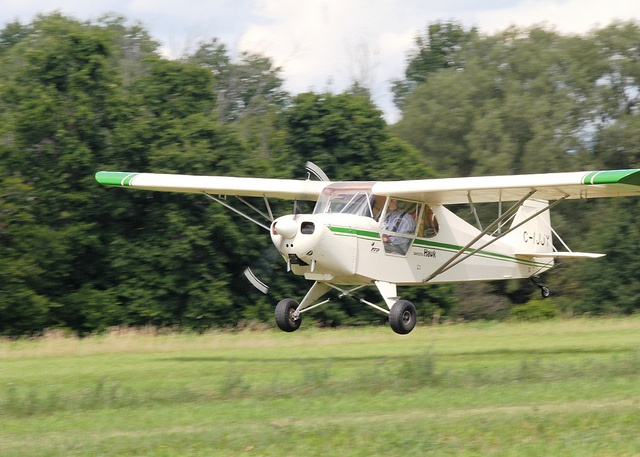Describe the objects in this image and their specific colors. I can see airplane in white, black, tan, and gray tones and people in white, darkgray, and gray tones in this image. 